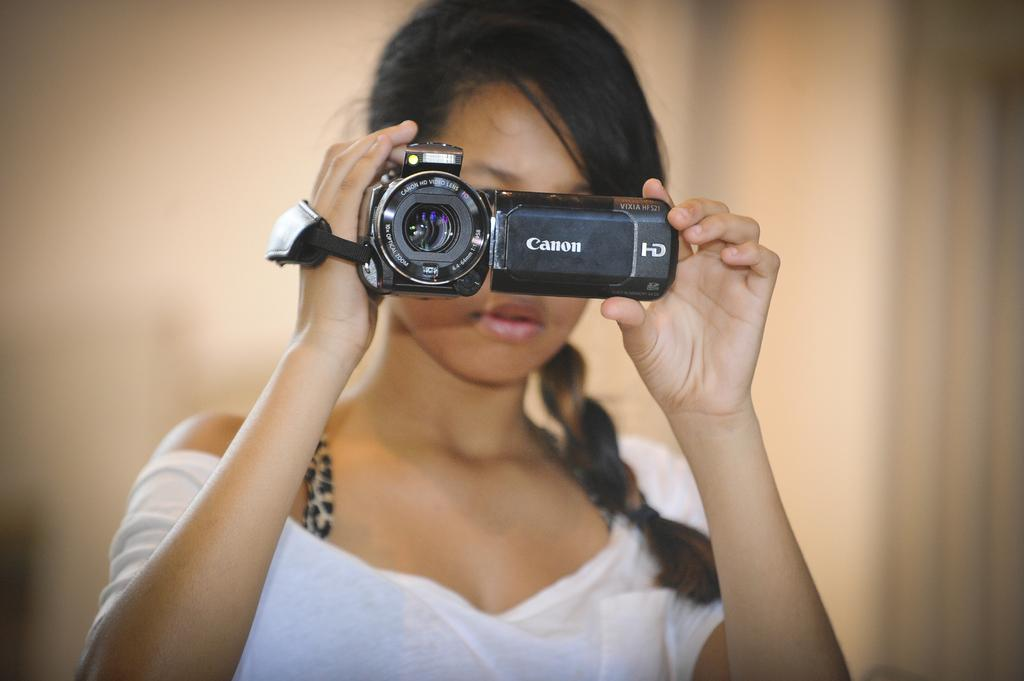What is the main subject of the image? There is a woman in the image. What is the woman doing in the image? The woman is standing and holding a camera in her hand. What can be observed about the background of the image? The background color is light brown. Where was the image taken? The image was taken inside a house. How many drawers can be seen in the image? There are no drawers present in the image. What type of breath is the woman taking in the image? There is no indication of the woman's breathing in the image. 